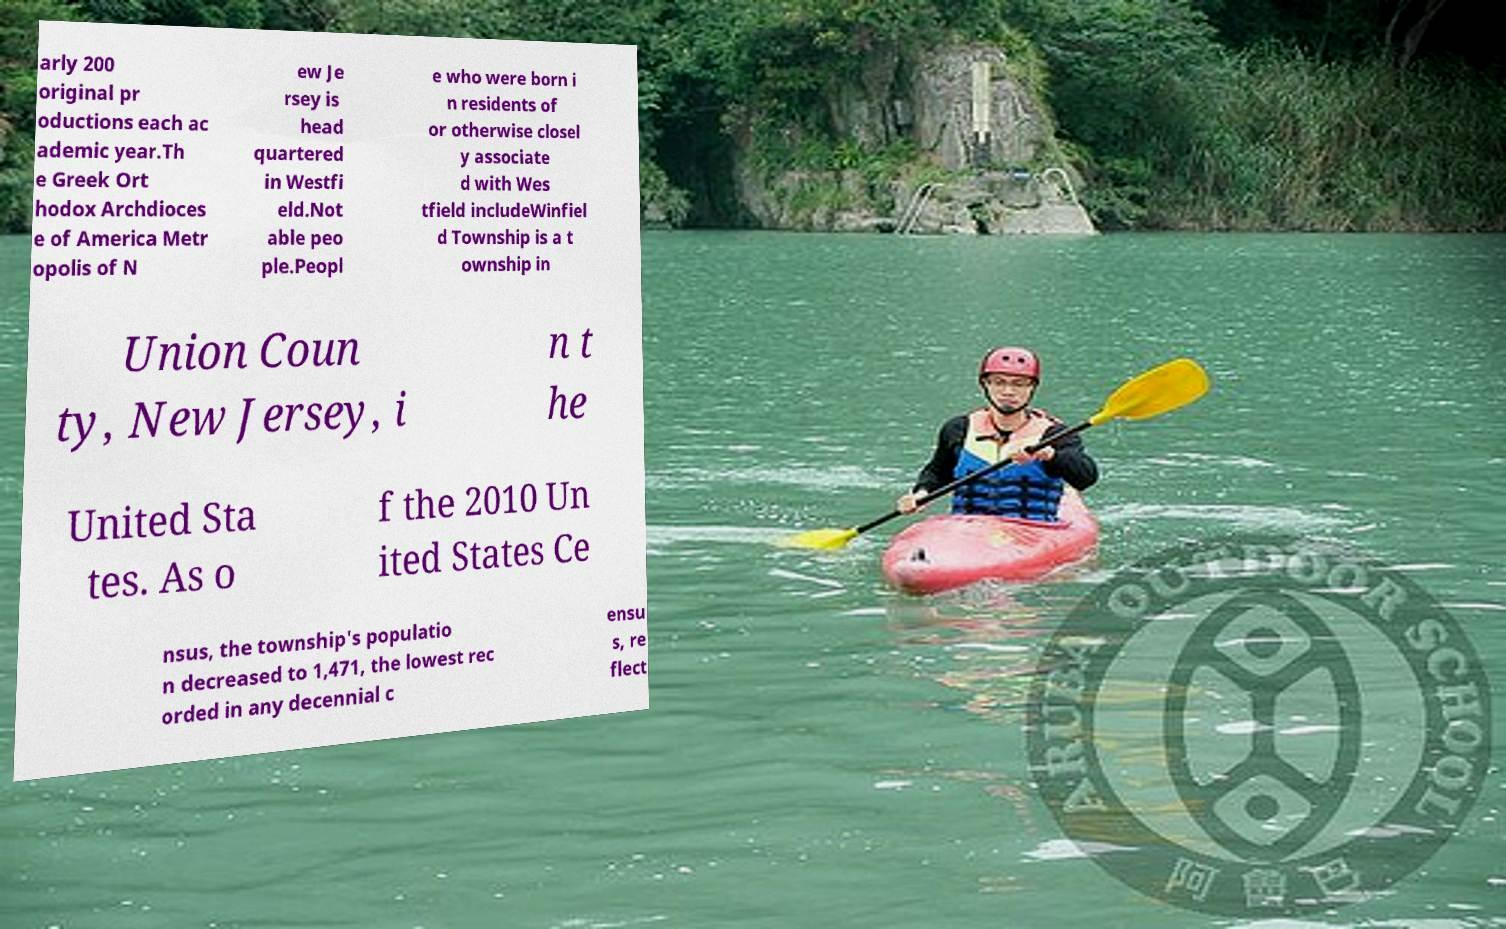For documentation purposes, I need the text within this image transcribed. Could you provide that? arly 200 original pr oductions each ac ademic year.Th e Greek Ort hodox Archdioces e of America Metr opolis of N ew Je rsey is head quartered in Westfi eld.Not able peo ple.Peopl e who were born i n residents of or otherwise closel y associate d with Wes tfield includeWinfiel d Township is a t ownship in Union Coun ty, New Jersey, i n t he United Sta tes. As o f the 2010 Un ited States Ce nsus, the township's populatio n decreased to 1,471, the lowest rec orded in any decennial c ensu s, re flect 